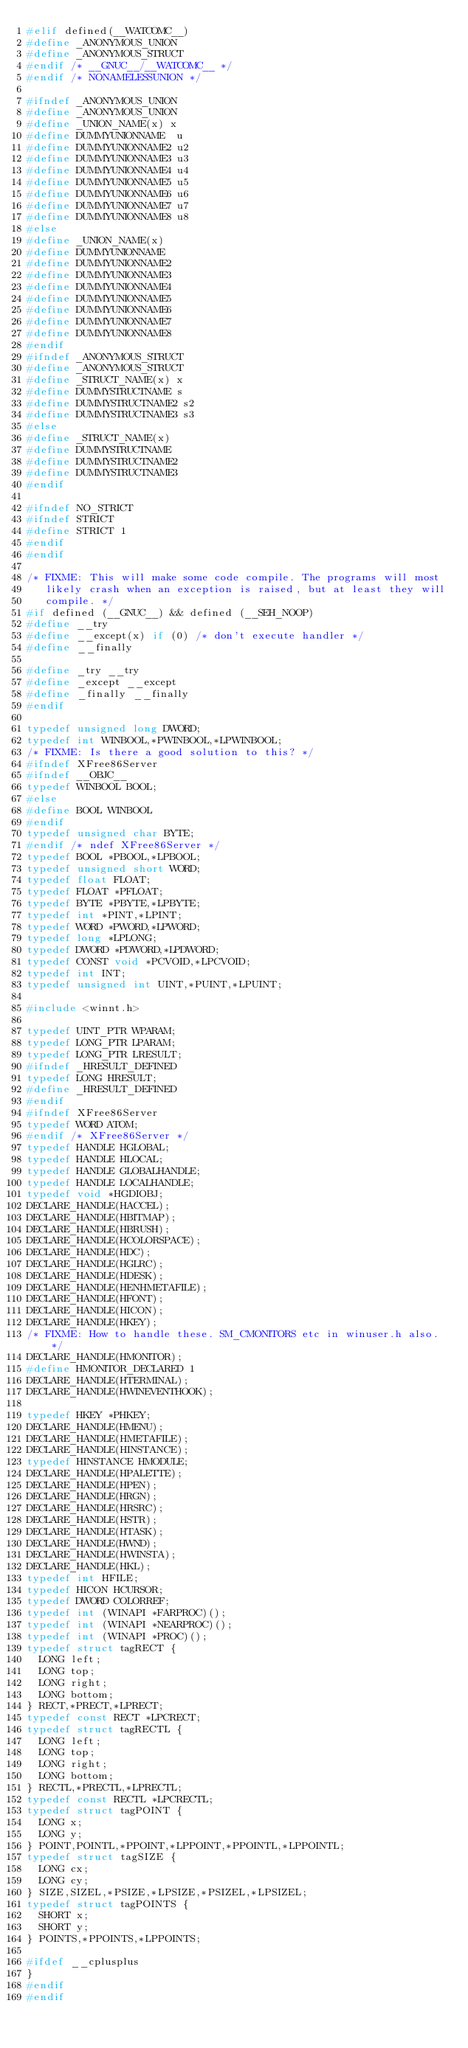<code> <loc_0><loc_0><loc_500><loc_500><_C_>#elif defined(__WATCOMC__)
#define _ANONYMOUS_UNION
#define _ANONYMOUS_STRUCT
#endif /* __GNUC__/__WATCOMC__ */
#endif /* NONAMELESSUNION */

#ifndef _ANONYMOUS_UNION
#define _ANONYMOUS_UNION
#define _UNION_NAME(x) x
#define DUMMYUNIONNAME	u
#define DUMMYUNIONNAME2	u2
#define DUMMYUNIONNAME3	u3
#define DUMMYUNIONNAME4	u4
#define DUMMYUNIONNAME5	u5
#define DUMMYUNIONNAME6	u6
#define DUMMYUNIONNAME7	u7
#define DUMMYUNIONNAME8	u8
#else
#define _UNION_NAME(x)
#define DUMMYUNIONNAME
#define DUMMYUNIONNAME2
#define DUMMYUNIONNAME3
#define DUMMYUNIONNAME4
#define DUMMYUNIONNAME5
#define DUMMYUNIONNAME6
#define DUMMYUNIONNAME7
#define DUMMYUNIONNAME8
#endif
#ifndef _ANONYMOUS_STRUCT
#define _ANONYMOUS_STRUCT
#define _STRUCT_NAME(x) x
#define DUMMYSTRUCTNAME	s
#define DUMMYSTRUCTNAME2 s2
#define DUMMYSTRUCTNAME3 s3
#else
#define _STRUCT_NAME(x)
#define DUMMYSTRUCTNAME
#define DUMMYSTRUCTNAME2
#define DUMMYSTRUCTNAME3
#endif

#ifndef NO_STRICT
#ifndef STRICT
#define STRICT 1
#endif
#endif

/* FIXME: This will make some code compile. The programs will most
   likely crash when an exception is raised, but at least they will
   compile. */
#if defined (__GNUC__) && defined (__SEH_NOOP)
#define __try
#define __except(x) if (0) /* don't execute handler */
#define __finally

#define _try __try
#define _except __except
#define _finally __finally
#endif

typedef unsigned long DWORD;
typedef int WINBOOL,*PWINBOOL,*LPWINBOOL;
/* FIXME: Is there a good solution to this? */
#ifndef XFree86Server
#ifndef __OBJC__
typedef WINBOOL BOOL;
#else
#define BOOL WINBOOL
#endif
typedef unsigned char BYTE;
#endif /* ndef XFree86Server */
typedef BOOL *PBOOL,*LPBOOL;
typedef unsigned short WORD;
typedef float FLOAT;
typedef FLOAT *PFLOAT;
typedef BYTE *PBYTE,*LPBYTE;
typedef int *PINT,*LPINT;
typedef WORD *PWORD,*LPWORD;
typedef long *LPLONG;
typedef DWORD *PDWORD,*LPDWORD;
typedef CONST void *PCVOID,*LPCVOID;
typedef int INT;
typedef unsigned int UINT,*PUINT,*LPUINT;

#include <winnt.h>

typedef UINT_PTR WPARAM;
typedef LONG_PTR LPARAM;
typedef LONG_PTR LRESULT;
#ifndef _HRESULT_DEFINED
typedef LONG HRESULT;
#define _HRESULT_DEFINED
#endif
#ifndef XFree86Server
typedef WORD ATOM;
#endif /* XFree86Server */
typedef HANDLE HGLOBAL;
typedef HANDLE HLOCAL;
typedef HANDLE GLOBALHANDLE;
typedef HANDLE LOCALHANDLE;
typedef void *HGDIOBJ;
DECLARE_HANDLE(HACCEL);
DECLARE_HANDLE(HBITMAP);
DECLARE_HANDLE(HBRUSH);
DECLARE_HANDLE(HCOLORSPACE);
DECLARE_HANDLE(HDC);
DECLARE_HANDLE(HGLRC);
DECLARE_HANDLE(HDESK);
DECLARE_HANDLE(HENHMETAFILE);
DECLARE_HANDLE(HFONT);
DECLARE_HANDLE(HICON);
DECLARE_HANDLE(HKEY);
/* FIXME: How to handle these. SM_CMONITORS etc in winuser.h also. */
DECLARE_HANDLE(HMONITOR);
#define HMONITOR_DECLARED 1
DECLARE_HANDLE(HTERMINAL);
DECLARE_HANDLE(HWINEVENTHOOK);

typedef HKEY *PHKEY;
DECLARE_HANDLE(HMENU);
DECLARE_HANDLE(HMETAFILE);
DECLARE_HANDLE(HINSTANCE);
typedef HINSTANCE HMODULE;
DECLARE_HANDLE(HPALETTE);
DECLARE_HANDLE(HPEN);
DECLARE_HANDLE(HRGN);
DECLARE_HANDLE(HRSRC);
DECLARE_HANDLE(HSTR);
DECLARE_HANDLE(HTASK);
DECLARE_HANDLE(HWND);
DECLARE_HANDLE(HWINSTA);
DECLARE_HANDLE(HKL);
typedef int HFILE;
typedef HICON HCURSOR;
typedef DWORD COLORREF;
typedef int (WINAPI *FARPROC)();
typedef int (WINAPI *NEARPROC)();
typedef int (WINAPI *PROC)();
typedef struct tagRECT {
	LONG left;
	LONG top;
	LONG right;
	LONG bottom;
} RECT,*PRECT,*LPRECT;
typedef const RECT *LPCRECT;
typedef struct tagRECTL {
	LONG left;
	LONG top;
	LONG right;
	LONG bottom;
} RECTL,*PRECTL,*LPRECTL;
typedef const RECTL *LPCRECTL;
typedef struct tagPOINT {
	LONG x;
	LONG y;
} POINT,POINTL,*PPOINT,*LPPOINT,*PPOINTL,*LPPOINTL;
typedef struct tagSIZE {
	LONG cx;
	LONG cy;
} SIZE,SIZEL,*PSIZE,*LPSIZE,*PSIZEL,*LPSIZEL;
typedef struct tagPOINTS {
	SHORT x;
	SHORT y;
} POINTS,*PPOINTS,*LPPOINTS;

#ifdef __cplusplus
}
#endif
#endif
</code> 